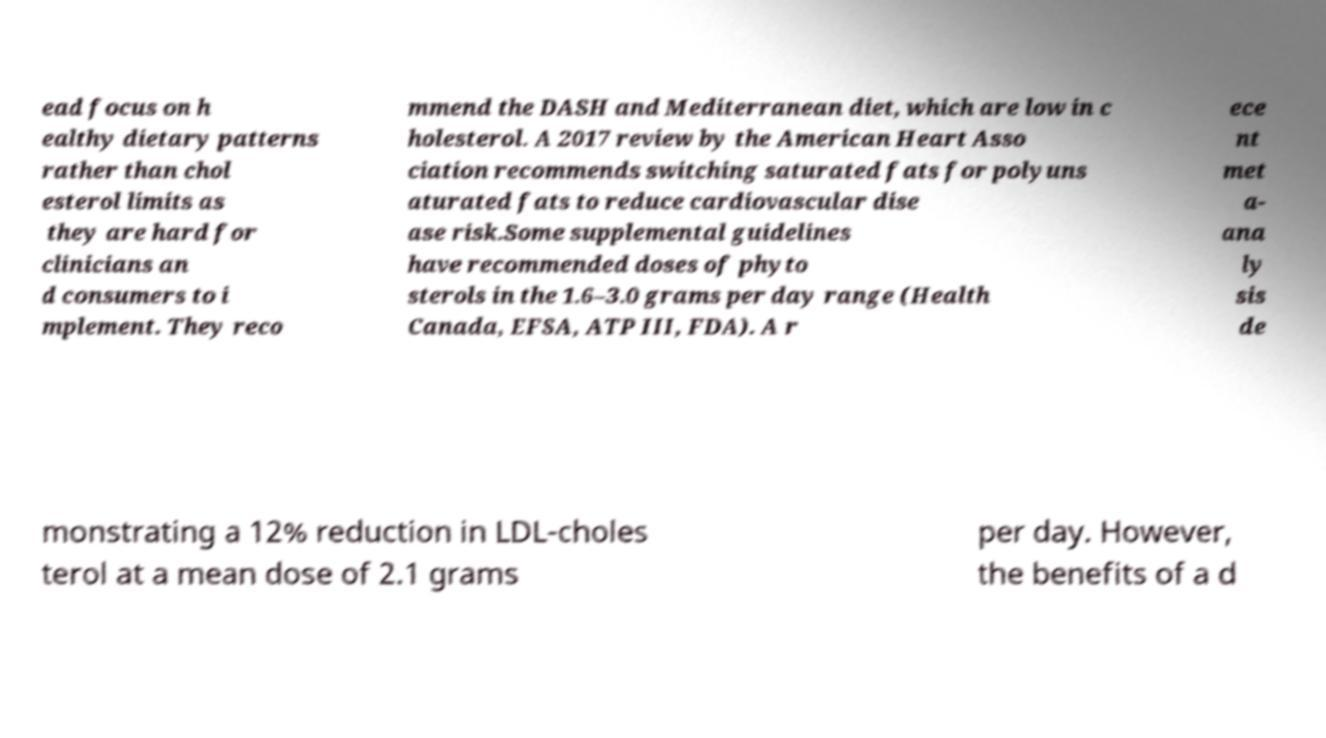Could you extract and type out the text from this image? ead focus on h ealthy dietary patterns rather than chol esterol limits as they are hard for clinicians an d consumers to i mplement. They reco mmend the DASH and Mediterranean diet, which are low in c holesterol. A 2017 review by the American Heart Asso ciation recommends switching saturated fats for polyuns aturated fats to reduce cardiovascular dise ase risk.Some supplemental guidelines have recommended doses of phyto sterols in the 1.6–3.0 grams per day range (Health Canada, EFSA, ATP III, FDA). A r ece nt met a- ana ly sis de monstrating a 12% reduction in LDL-choles terol at a mean dose of 2.1 grams per day. However, the benefits of a d 